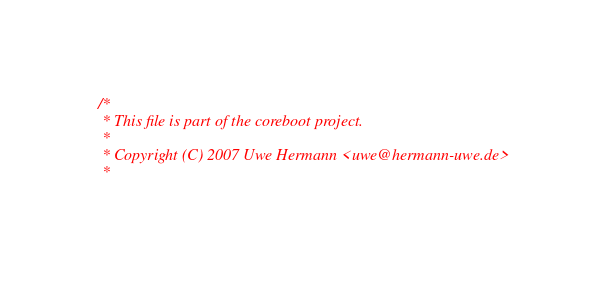Convert code to text. <code><loc_0><loc_0><loc_500><loc_500><_C_>/*
 * This file is part of the coreboot project.
 *
 * Copyright (C) 2007 Uwe Hermann <uwe@hermann-uwe.de>
 *</code> 